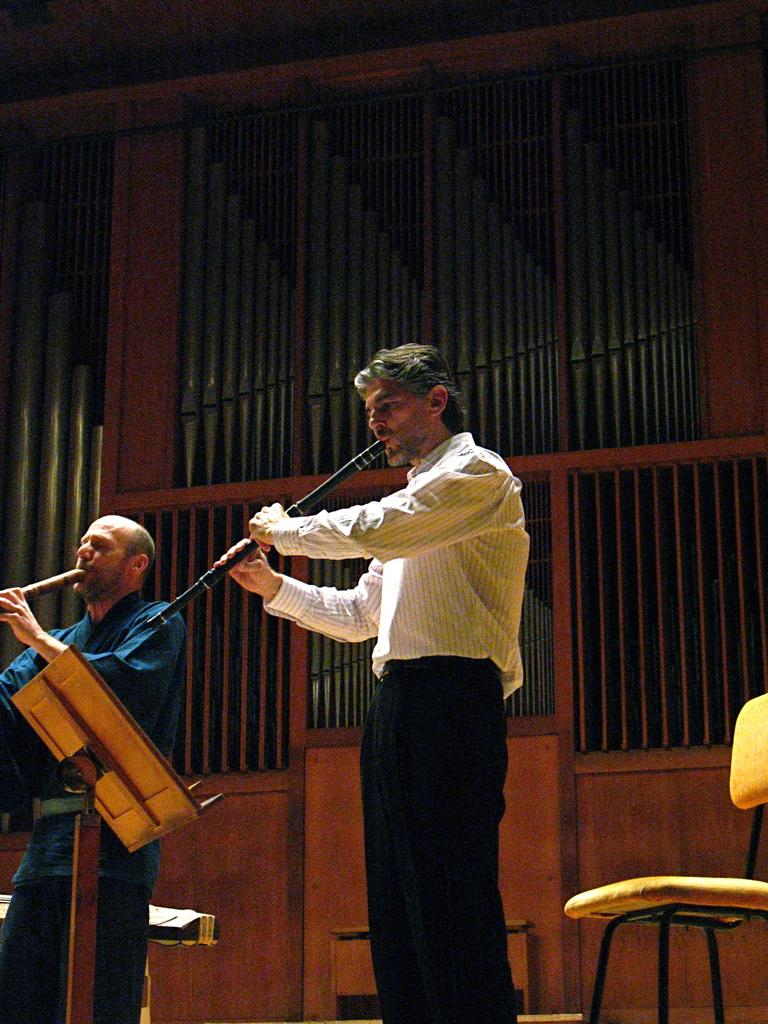How many people are in the image? There are two men in the image. What are the men doing in the image? The men are standing and playing musical instruments. Can you describe the wooden object in the image? There is a wooden object in the image, but its specific details are not mentioned. What else can be seen in the image besides the men and the wooden object? There are other objects in the image, but their specific details are not mentioned. What is visible in the background of the image? There is a wall in the background of the image. What type of birds are flying over the men in the image? There are no birds visible in the image. What trade agreement is being discussed by the men in the image? There is no indication of a trade agreement or any discussion in the image. 